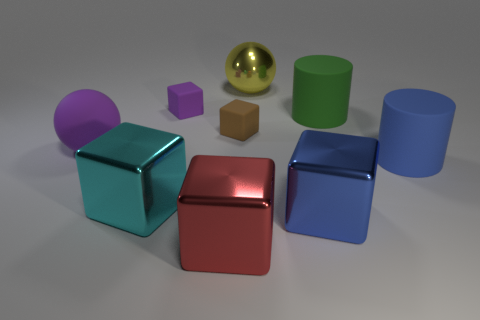There is a thing that is the same color as the big rubber ball; what size is it?
Keep it short and to the point. Small. Is the color of the tiny block left of the red thing the same as the big matte ball?
Make the answer very short. Yes. What number of other green objects are the same size as the green object?
Your answer should be very brief. 0. Are there any small cubes of the same color as the rubber sphere?
Offer a very short reply. Yes. Are the big purple ball and the big red block made of the same material?
Offer a terse response. No. What number of big yellow metal things have the same shape as the big purple thing?
Ensure brevity in your answer.  1. What shape is the big yellow object that is made of the same material as the large red cube?
Offer a very short reply. Sphere. There is a ball on the left side of the ball behind the green matte object; what color is it?
Provide a succinct answer. Purple. What is the material of the sphere that is right of the ball that is left of the tiny brown rubber block?
Provide a short and direct response. Metal. What material is the purple object that is the same shape as the big red metal thing?
Your response must be concise. Rubber. 